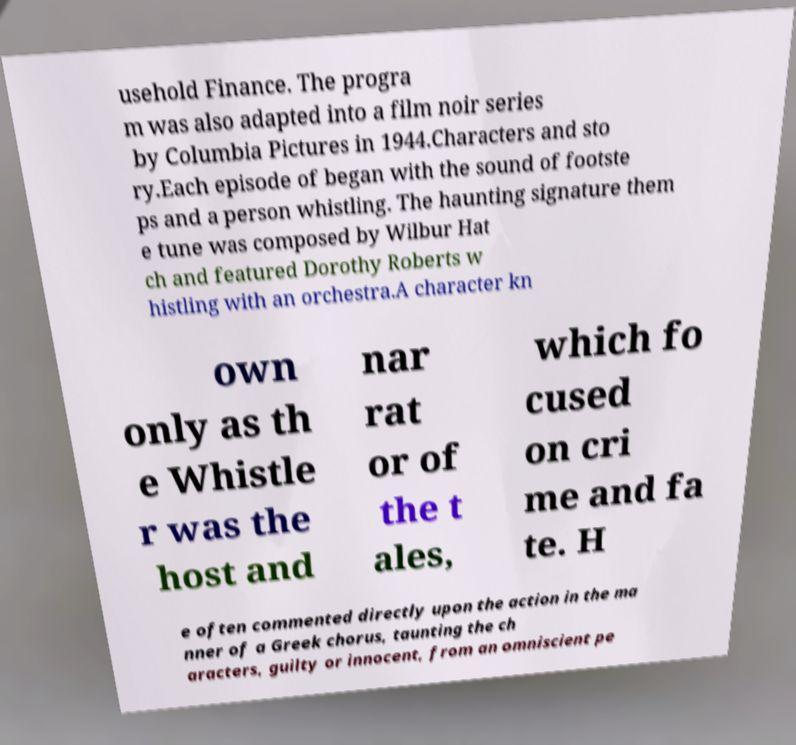I need the written content from this picture converted into text. Can you do that? usehold Finance. The progra m was also adapted into a film noir series by Columbia Pictures in 1944.Characters and sto ry.Each episode of began with the sound of footste ps and a person whistling. The haunting signature them e tune was composed by Wilbur Hat ch and featured Dorothy Roberts w histling with an orchestra.A character kn own only as th e Whistle r was the host and nar rat or of the t ales, which fo cused on cri me and fa te. H e often commented directly upon the action in the ma nner of a Greek chorus, taunting the ch aracters, guilty or innocent, from an omniscient pe 